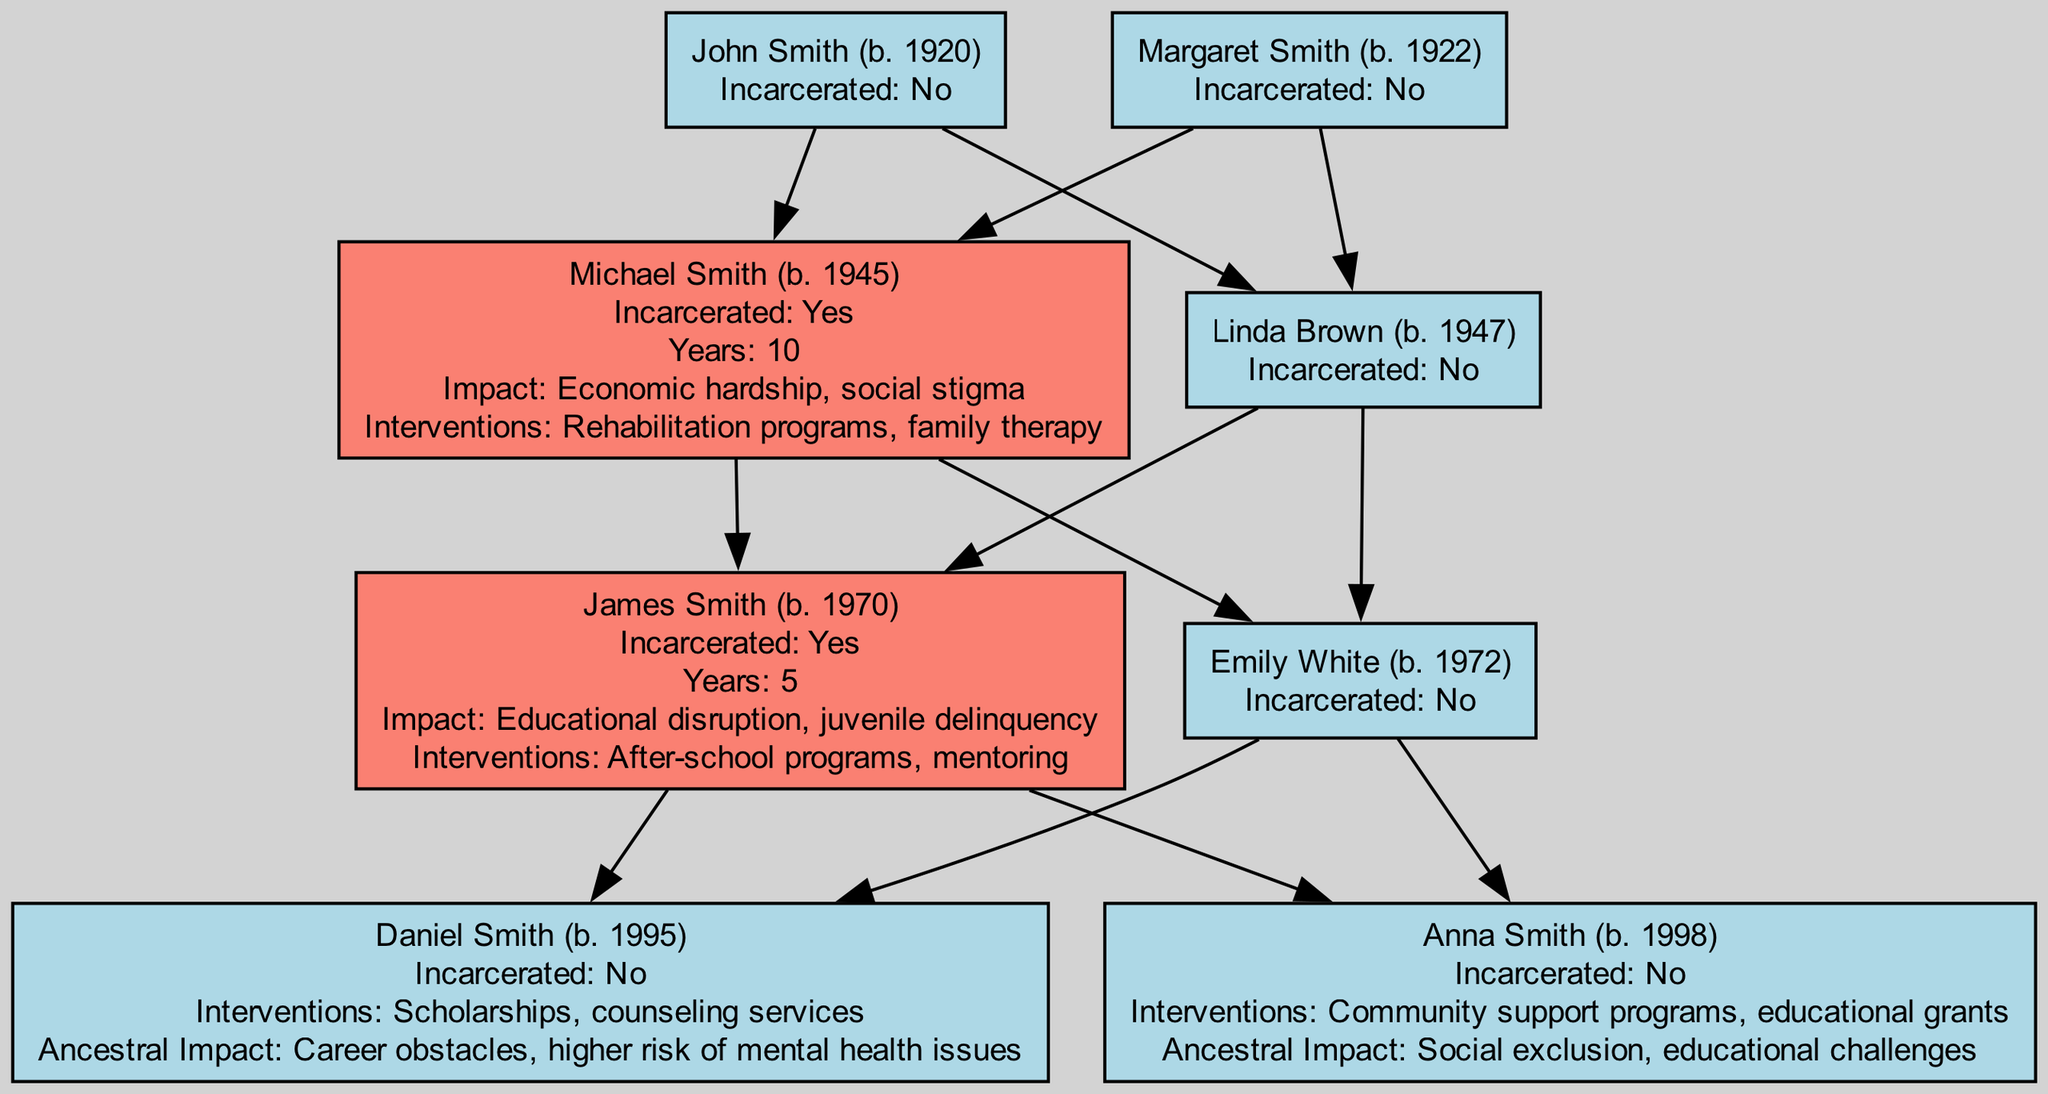What is the birth year of John Smith? The diagram shows that John Smith's details include the "BirthYear" field with the value 1920. Therefore, the birth year of John Smith is 1920.
Answer: 1920 How many years was Michael Smith incarcerated? The diagram indicates that Michael Smith has an "IncarcerationHistory" and a corresponding "YearsIncarcerated" value of 10. Thus, Michael Smith was incarcerated for 10 years.
Answer: 10 What is the impact of James Smith's incarceration on his family? The diagram states that James Smith has an "ImpactOnFamily" listed as "Educational disruption, juvenile delinquency". This clearly articulates how his incarceration affected his family.
Answer: Educational disruption, juvenile delinquency What interventions were implemented for Daniel Smith? According to the diagram, Daniel Smith received "Scholarships, counseling services" as his "Interventions". These are the specific interventions designed to support him.
Answer: Scholarships, counseling services Which member of the current generation has been impacted by social exclusion? The diagram specifies that Anna Smith has noted "Social exclusion, educational challenges" as her "ImpactOnLifeDueToAncestors". Hence, Anna Smith is the member affected by social exclusion.
Answer: Anna Smith Are any of the great grandparents incarcerated? The diagram displays that both John Smith and Margaret Smith have an "IncarcerationHistory" of "No", indicating neither of them is incarcerated. Therefore, the answer is no.
Answer: No What is the pattern of incarceration in this family tree across generations? By examining the diagram, we see that incarceration appears in the Grandparents and Parents levels, specifically with Michael Smith and James Smith, indicating a familial pattern of incarceration across generations.
Answer: Incarceration in Grandparents and Parents How many total members are in the Grandparents generation? The diagram shows that there are two members in the Grandparents generation: Michael Smith and Linda Brown. Thus, the total number of members is 2.
Answer: 2 What type of impact did Daniel Smith experience as a result of his ancestors? The diagram indicates that Daniel Smith's "ImpactOnLifeDueToAncestors" is characterized by "Career obstacles, higher risk of mental health issues". This describes the specific impact he faces.
Answer: Career obstacles, higher risk of mental health issues 